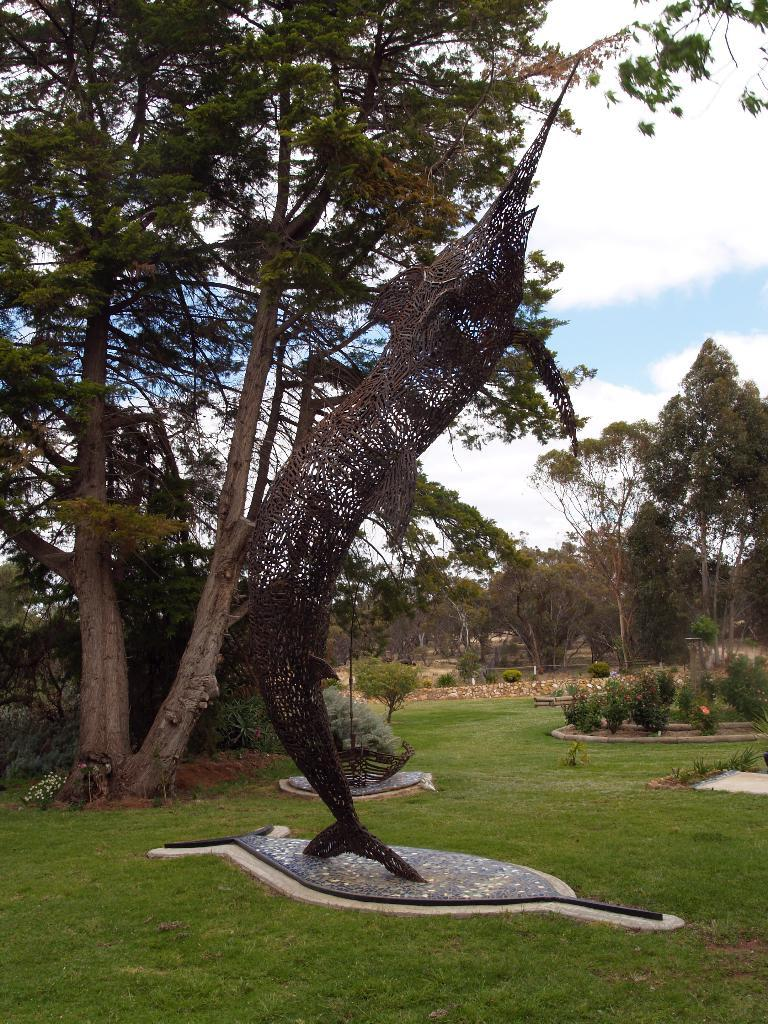What type of vegetation can be seen in the image? There is grass in the image. What is the color of the structure in the image? The structure in the image is black. What other types of vegetation are present in the image? There are trees and plants in the image. What can be seen in the background of the image? The sky is visible in the background of the image. What type of copper object is being shaken by the goat in the image? There is no goat or copper object present in the image. How does the goat interact with the copper object in the image? Since there is no goat or copper object in the image, it is not possible to describe any interaction between them. 